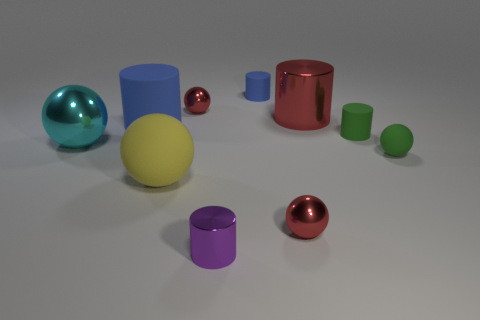How many large things are cyan objects or green shiny objects?
Your response must be concise. 1. How many things are either small red metal objects that are in front of the green sphere or large blue metallic balls?
Keep it short and to the point. 1. Does the large metallic cylinder have the same color as the large matte cylinder?
Ensure brevity in your answer.  No. How many other things are the same shape as the cyan object?
Provide a succinct answer. 4. How many purple things are cylinders or matte balls?
Offer a very short reply. 1. The other cylinder that is made of the same material as the small purple cylinder is what color?
Keep it short and to the point. Red. Does the small ball that is on the left side of the tiny metallic cylinder have the same material as the ball that is right of the red shiny cylinder?
Ensure brevity in your answer.  No. There is a thing that is the same color as the large rubber cylinder; what is its size?
Give a very brief answer. Small. What is the small red sphere that is right of the purple metal cylinder made of?
Offer a very short reply. Metal. There is a green object that is on the left side of the small green ball; is its shape the same as the tiny green object on the right side of the green cylinder?
Offer a very short reply. No. 